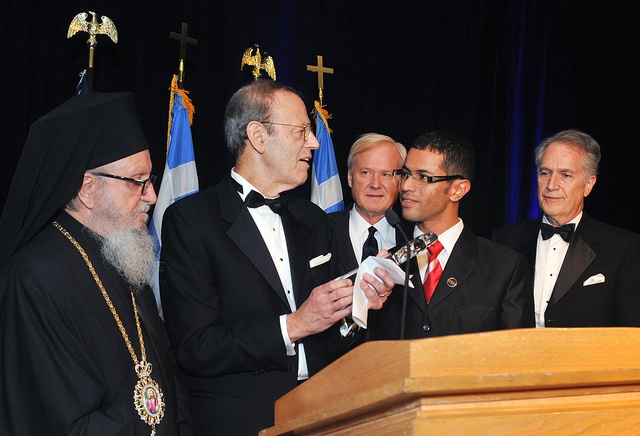Describe the objects in this image and their specific colors. I can see people in black, darkgray, tan, and gray tones, people in black, tan, white, and brown tones, people in black, salmon, and brown tones, people in black, ivory, salmon, and brown tones, and people in black, brown, lightgray, and salmon tones in this image. 